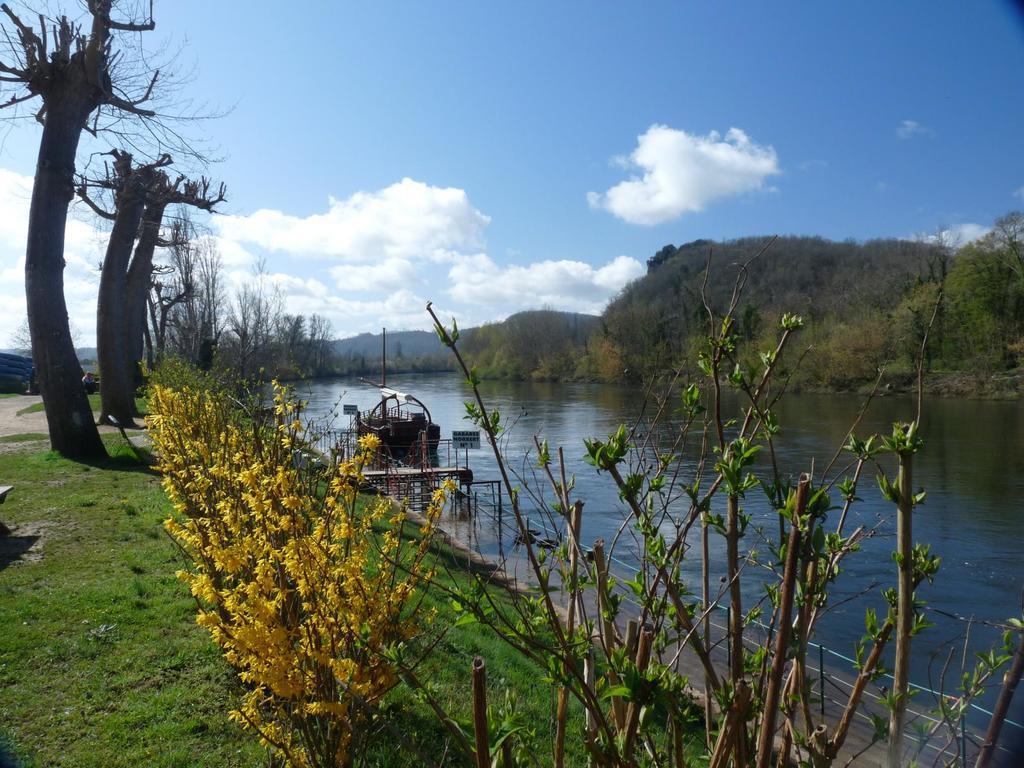Could you give a brief overview of what you see in this image? In this picture, we can see the ground, grass, dry trees, plants, trees, and we can see mountains, water, path above the water, boat and the sky with clouds. 